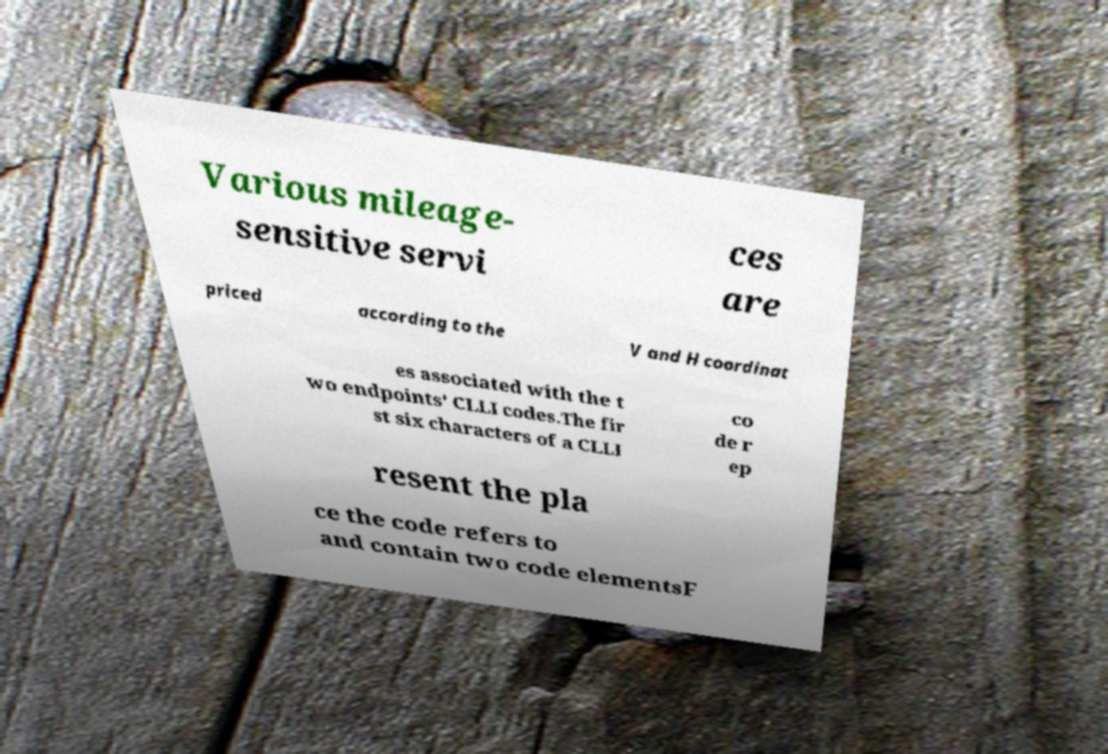Can you accurately transcribe the text from the provided image for me? Various mileage- sensitive servi ces are priced according to the V and H coordinat es associated with the t wo endpoints' CLLI codes.The fir st six characters of a CLLI co de r ep resent the pla ce the code refers to and contain two code elementsF 